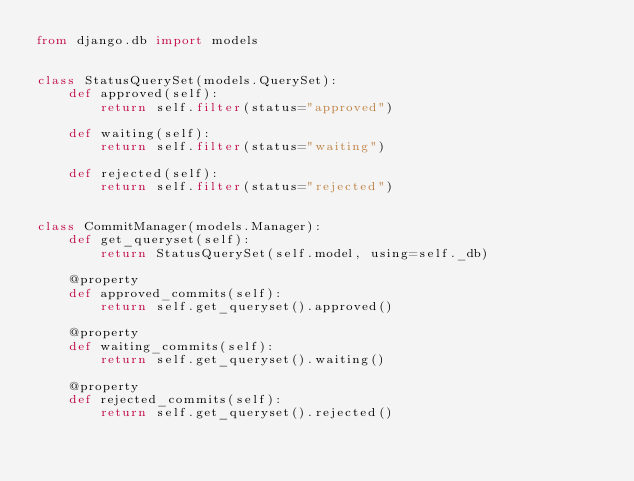Convert code to text. <code><loc_0><loc_0><loc_500><loc_500><_Python_>from django.db import models


class StatusQuerySet(models.QuerySet):
    def approved(self):
        return self.filter(status="approved")

    def waiting(self):
        return self.filter(status="waiting")

    def rejected(self):
        return self.filter(status="rejected")


class CommitManager(models.Manager):
    def get_queryset(self):
        return StatusQuerySet(self.model, using=self._db)

    @property
    def approved_commits(self):
        return self.get_queryset().approved()

    @property
    def waiting_commits(self):
        return self.get_queryset().waiting()

    @property
    def rejected_commits(self):
        return self.get_queryset().rejected()
</code> 